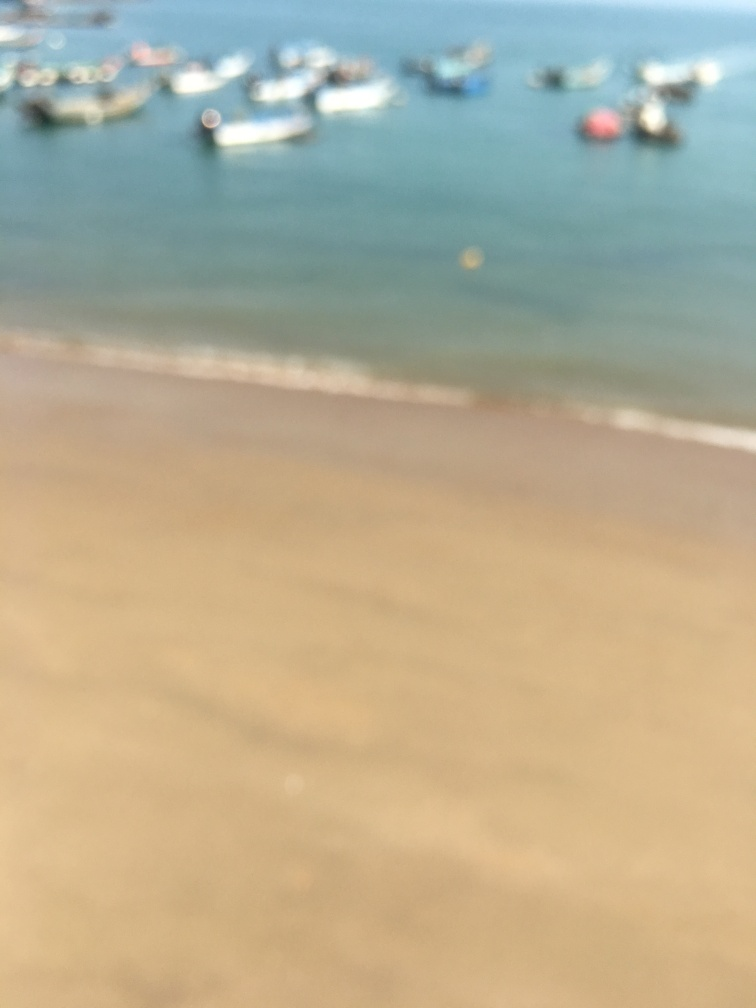What is the condition of the background?
A. Vividly colored
B. In focus
C. Clear and well-defined
D. Blurry and barely visible
Answer with the option's letter from the given choices directly.
 D. 